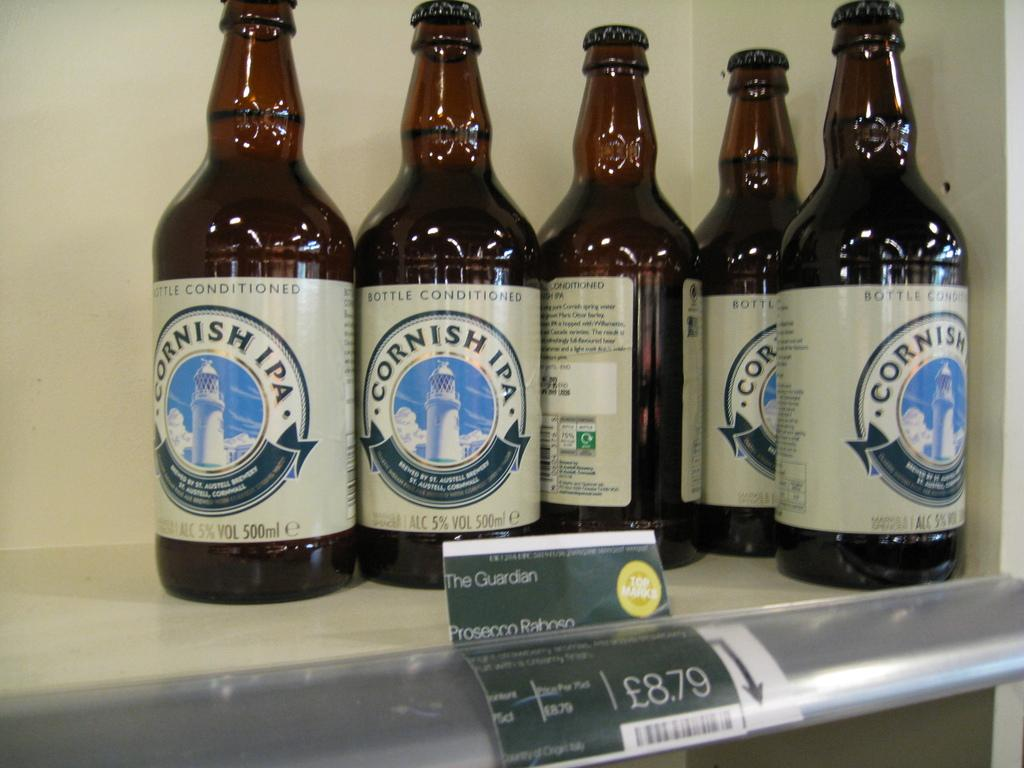<image>
Provide a brief description of the given image. The beer bottles pictures are hold 500mi of liquid each. 